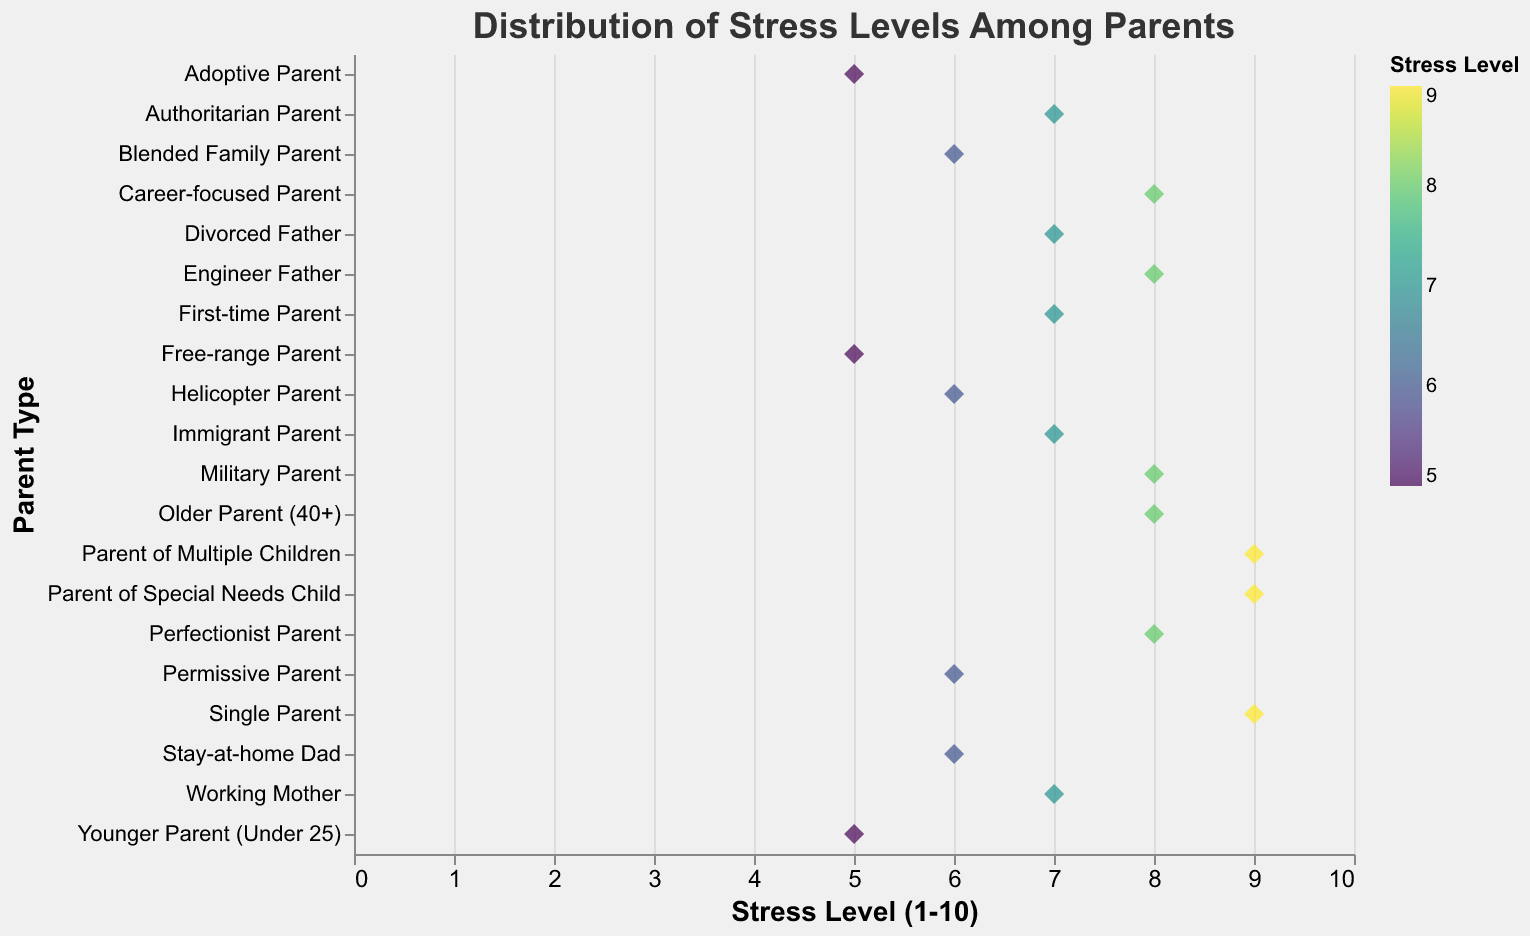What is the title of the figure? The title of the figure is usually placed at the top and helps to provide a context for the data being visualized. Here, the title should be read directly from the figure.
Answer: Distribution of Stress Levels Among Parents What is the range of the stress levels shown on the x-axis? The x-axis represents the range of stress levels measured on a scale. From the figure, this range can be identified between two specific values.
Answer: 0 to 10 Which parent type has the highest stress level? To determine the parent type with the highest stress level, look for the data point that is positioned farthest to the right on the x-axis.
Answer: Single Parent, Parent of Special Needs Child, Parent of Multiple Children (Stress Level 9) How many parent types have a stress level of 7? Count all the data points aligned at the stress level of 7 on the x-axis.
Answer: 5 What is the average stress level of all parents combined? To find the average, sum all the stress levels and divide by the number of parent types. The stress levels are: 8, 7, 6, 9, 5, 8, 7, 6, 9, 7, 8, 6, 5, 7, 9, 8, 6, 7, 8, 5. Sum: 151. Number of points: 20. Average = 151/20 = 7.55.
Answer: 7.55 Which parent type has the lowest stress level? Identify the data point positioned farthest to the left on the x-axis to find the lowest stress level.
Answer: Adoptive Parent, Free-range Parent, Younger Parent (Stress Level 5) How is the stress distribution differed among the parent types, visually? Visual inspection of the plot allows us to see how the stress levels are scattered or clustered among different parent types. Look for patterns or clustering along the x-axis. Explanation should focus on visible dense areas and outliers.
Answer: Stress levels vary widely among parent types, with several clustered around 7 and 8, and some clustered around 5 Which parent type's stress level exactly matches that of an "Engineer Father"? Locate the "Engineer Father" data point and match its stress level with other points. "Engineer Father" has a stress level of 8.
Answer: Military Parent, Perfectionist Parent, Career-focused Parent, Older Parent (40+) 